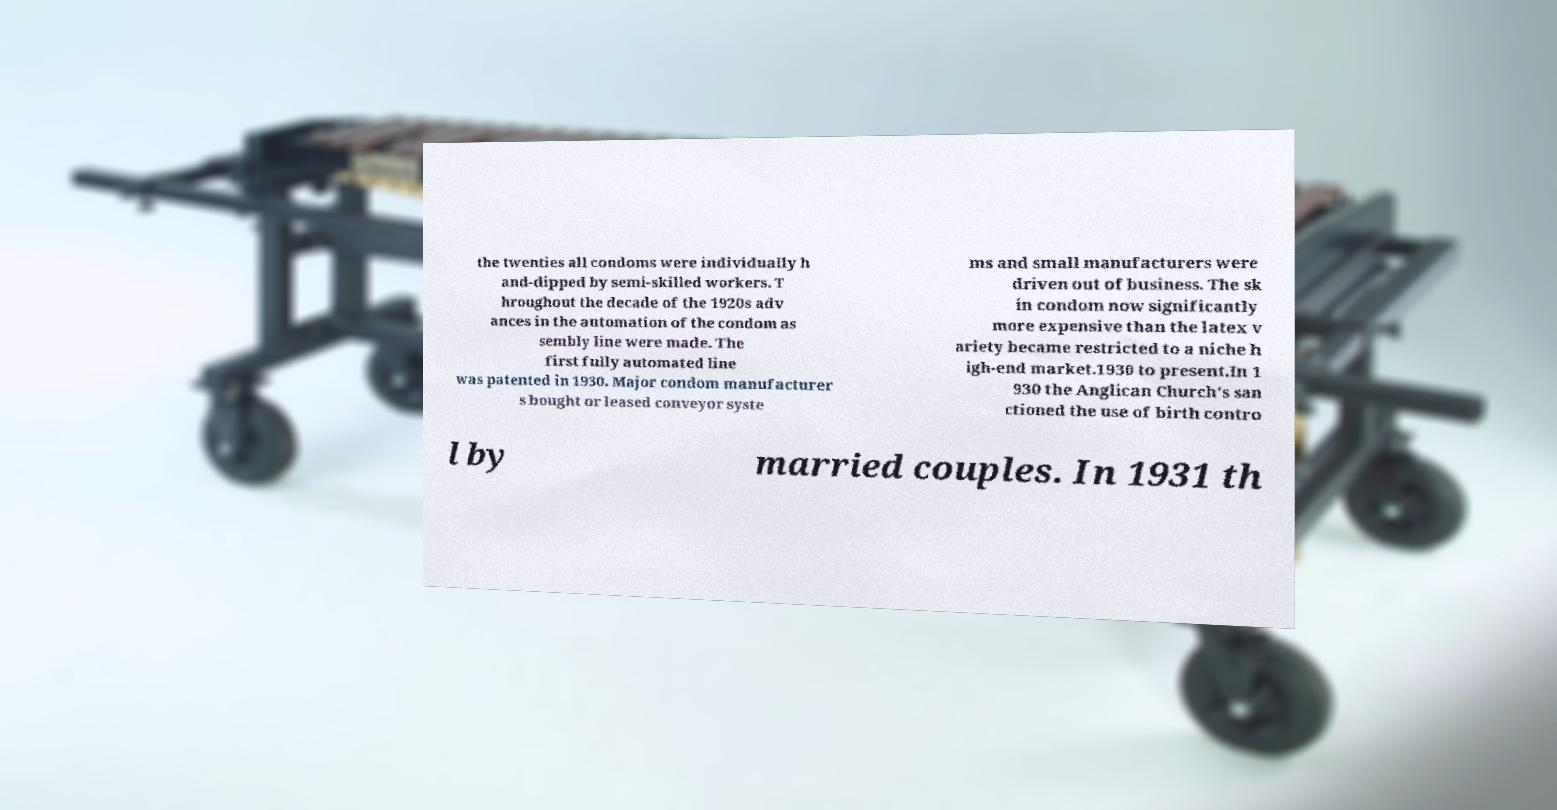Could you extract and type out the text from this image? the twenties all condoms were individually h and-dipped by semi-skilled workers. T hroughout the decade of the 1920s adv ances in the automation of the condom as sembly line were made. The first fully automated line was patented in 1930. Major condom manufacturer s bought or leased conveyor syste ms and small manufacturers were driven out of business. The sk in condom now significantly more expensive than the latex v ariety became restricted to a niche h igh-end market.1930 to present.In 1 930 the Anglican Church's san ctioned the use of birth contro l by married couples. In 1931 th 